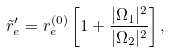<formula> <loc_0><loc_0><loc_500><loc_500>\tilde { r } _ { e } ^ { \prime } = r ^ { ( 0 ) } _ { e } \left [ 1 + \frac { | \Omega _ { 1 } | ^ { 2 } } { | \Omega _ { 2 } | ^ { 2 } } \right ] ,</formula> 